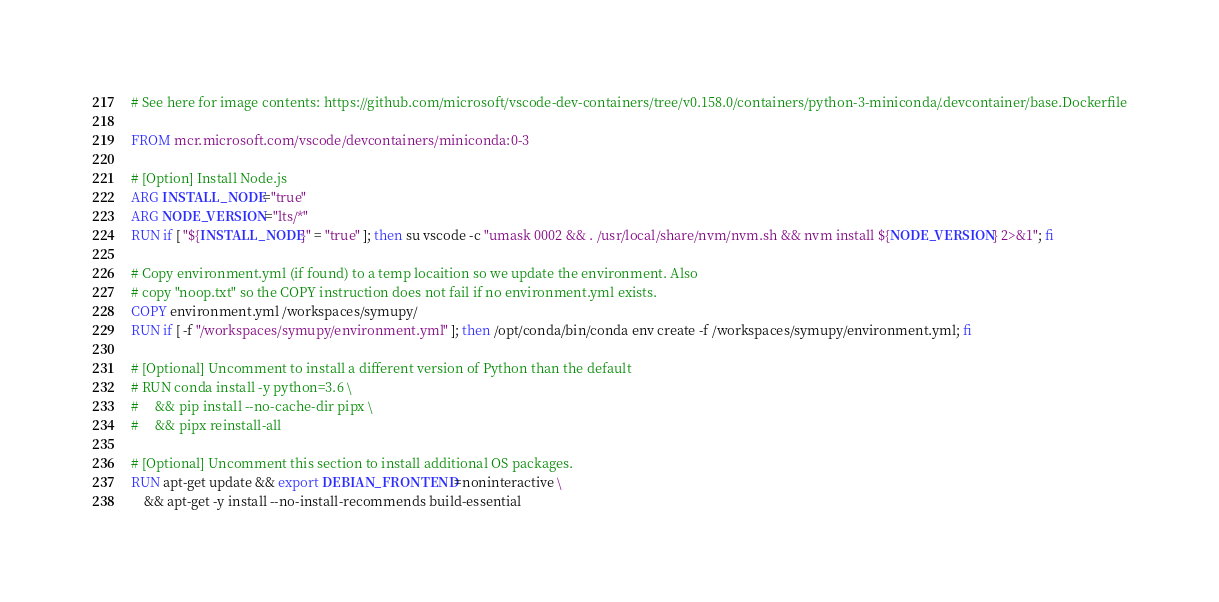<code> <loc_0><loc_0><loc_500><loc_500><_Dockerfile_># See here for image contents: https://github.com/microsoft/vscode-dev-containers/tree/v0.158.0/containers/python-3-miniconda/.devcontainer/base.Dockerfile

FROM mcr.microsoft.com/vscode/devcontainers/miniconda:0-3

# [Option] Install Node.js
ARG INSTALL_NODE="true"
ARG NODE_VERSION="lts/*"
RUN if [ "${INSTALL_NODE}" = "true" ]; then su vscode -c "umask 0002 && . /usr/local/share/nvm/nvm.sh && nvm install ${NODE_VERSION} 2>&1"; fi

# Copy environment.yml (if found) to a temp locaition so we update the environment. Also
# copy "noop.txt" so the COPY instruction does not fail if no environment.yml exists.
COPY environment.yml /workspaces/symupy/
RUN if [ -f "/workspaces/symupy/environment.yml" ]; then /opt/conda/bin/conda env create -f /workspaces/symupy/environment.yml; fi

# [Optional] Uncomment to install a different version of Python than the default
# RUN conda install -y python=3.6 \
#     && pip install --no-cache-dir pipx \
#     && pipx reinstall-all

# [Optional] Uncomment this section to install additional OS packages.
RUN apt-get update && export DEBIAN_FRONTEND=noninteractive \
    && apt-get -y install --no-install-recommends build-essential</code> 